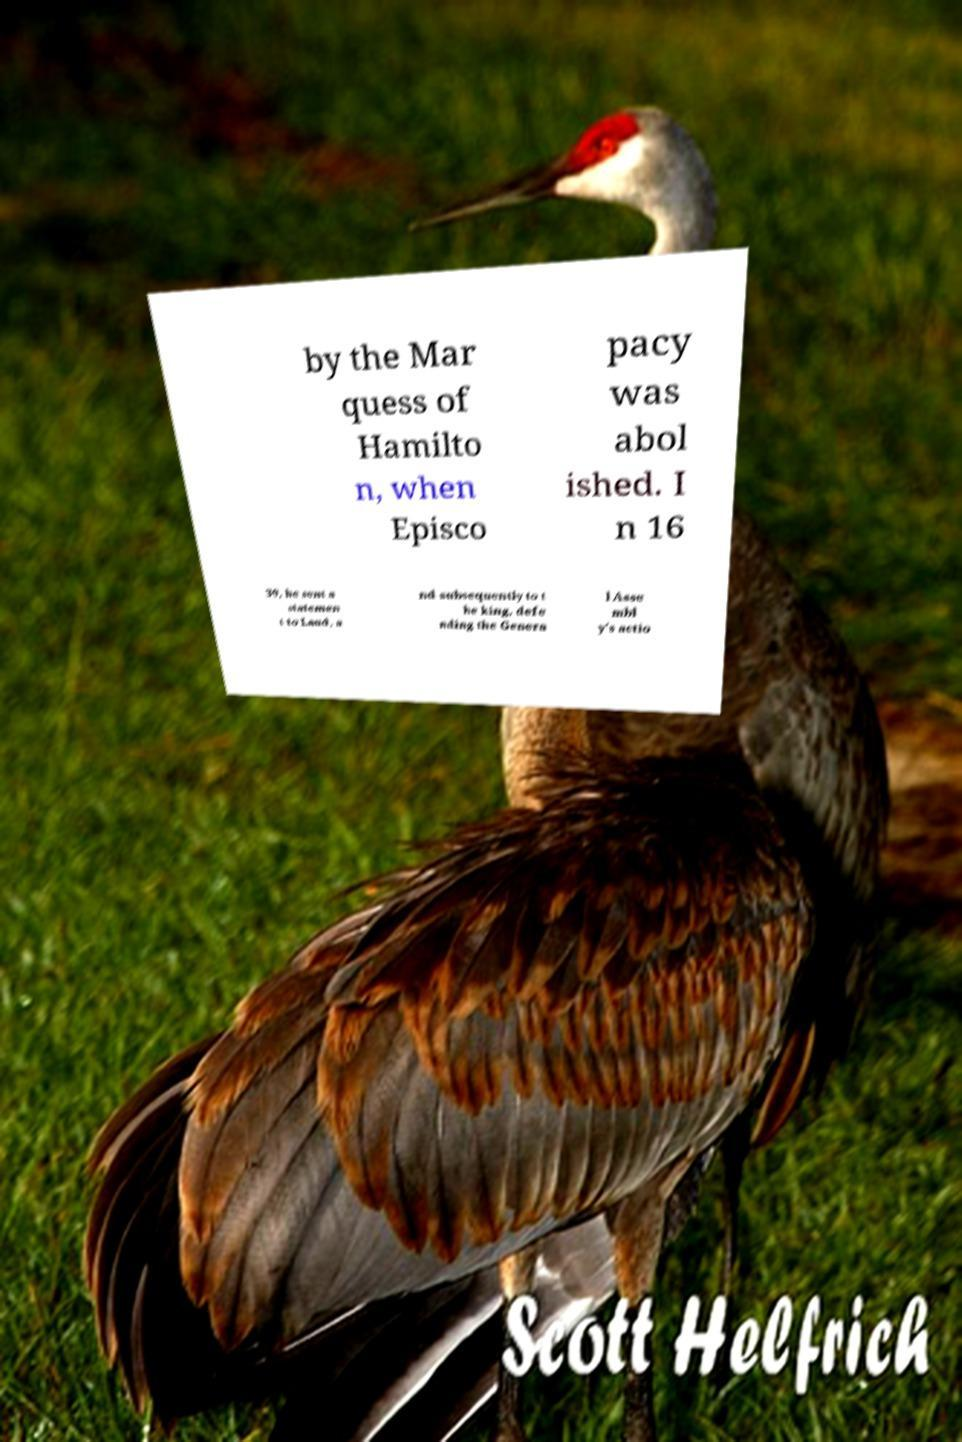Please identify and transcribe the text found in this image. by the Mar quess of Hamilto n, when Episco pacy was abol ished. I n 16 39, he sent a statemen t to Laud, a nd subsequently to t he king, defe nding the Genera l Asse mbl y's actio 